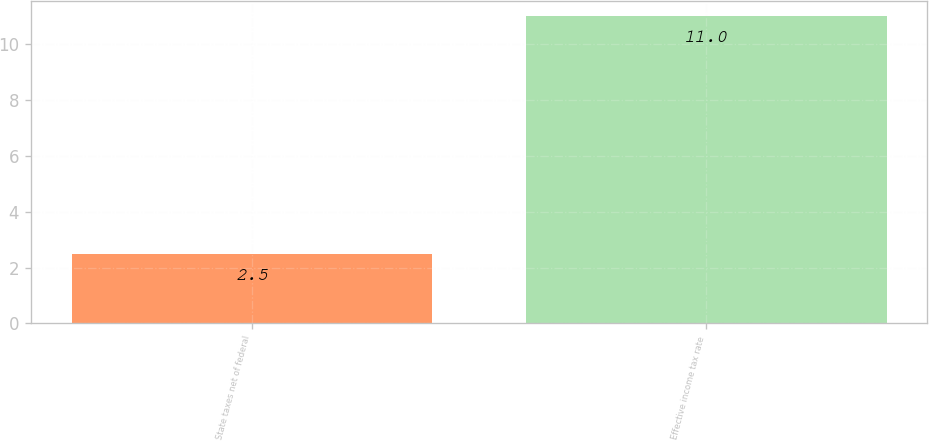<chart> <loc_0><loc_0><loc_500><loc_500><bar_chart><fcel>State taxes net of federal<fcel>Effective income tax rate<nl><fcel>2.5<fcel>11<nl></chart> 